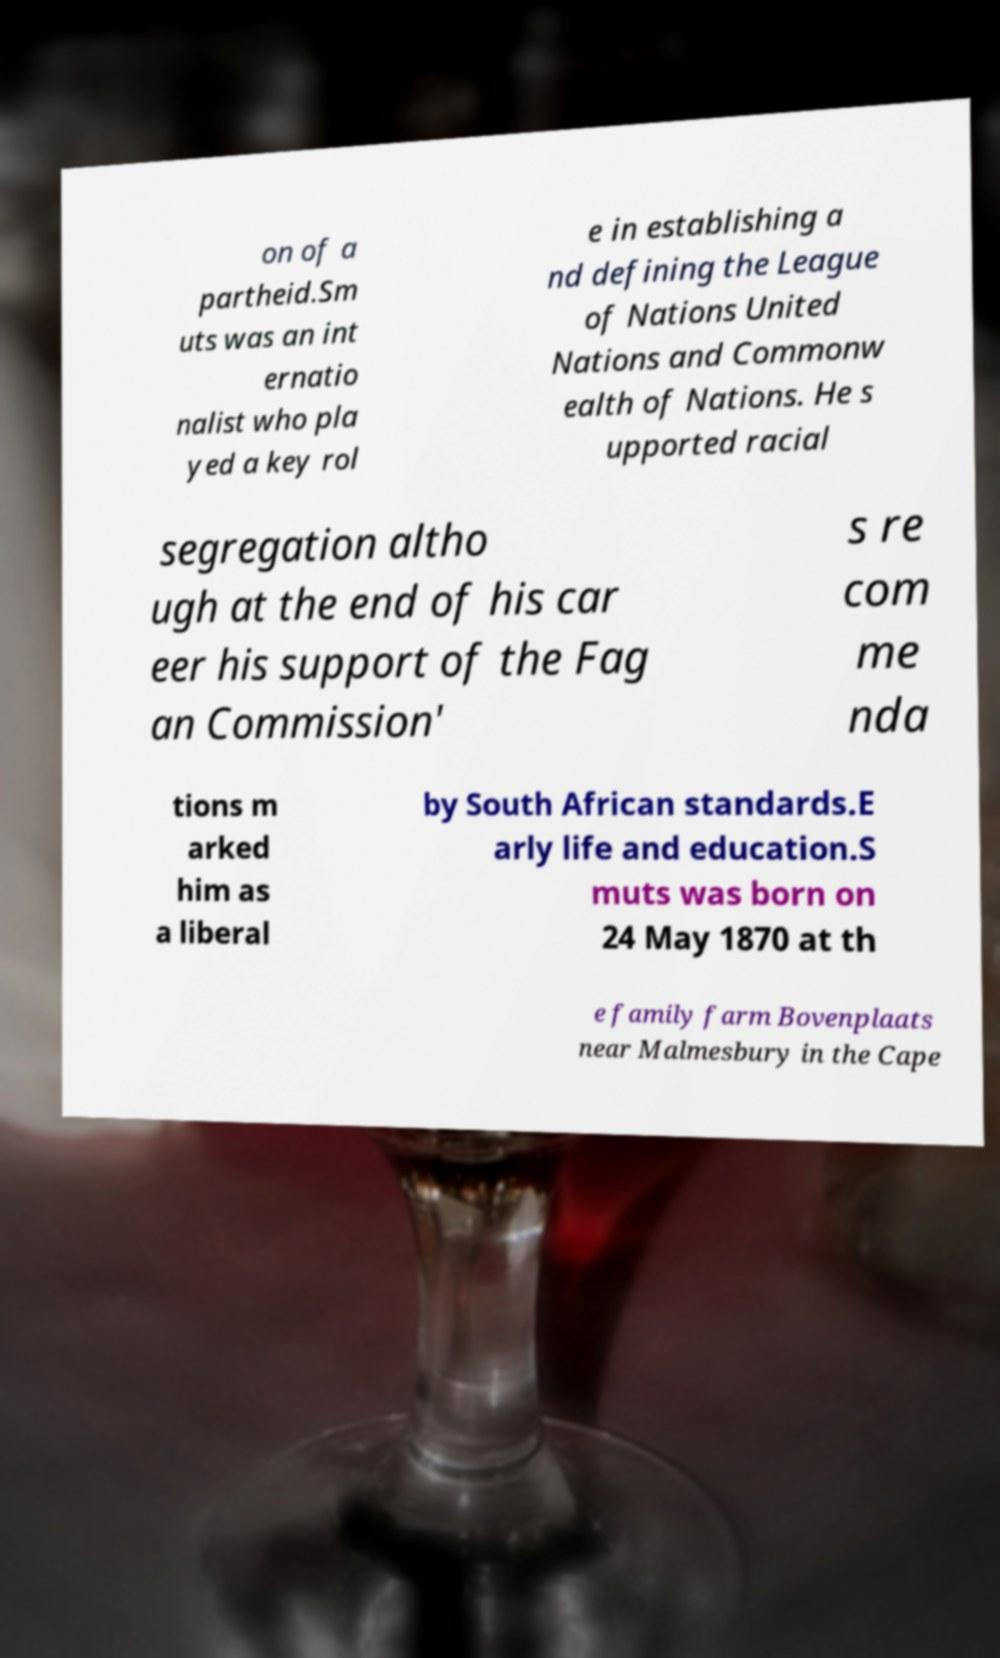I need the written content from this picture converted into text. Can you do that? on of a partheid.Sm uts was an int ernatio nalist who pla yed a key rol e in establishing a nd defining the League of Nations United Nations and Commonw ealth of Nations. He s upported racial segregation altho ugh at the end of his car eer his support of the Fag an Commission' s re com me nda tions m arked him as a liberal by South African standards.E arly life and education.S muts was born on 24 May 1870 at th e family farm Bovenplaats near Malmesbury in the Cape 